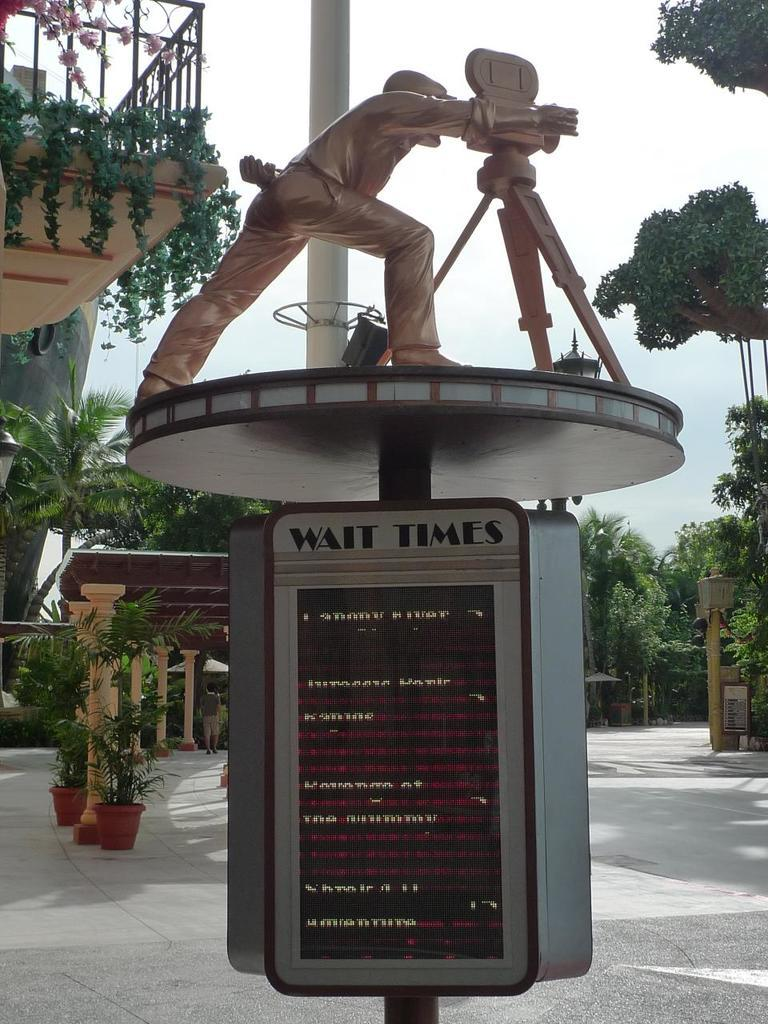What is the main subject in the center of the image? There is a statue in the center of the image. What can be seen in the background of the image? There are trees, buildings, pillars, and flower pots in the background of the image. Is there any indication of human presence in the image? Yes, there is a person visible in the image. What is at the bottom of the image? There is a road at the bottom of the image. What type of ring can be seen on the statue's finger in the image? There is no ring visible on the statue's finger in the image. What title does the statue hold in the image? The statue does not hold a title in the image; it is a sculpture and not a person. 